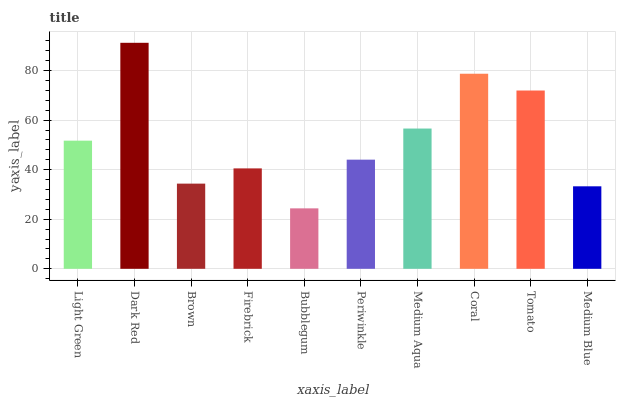Is Bubblegum the minimum?
Answer yes or no. Yes. Is Dark Red the maximum?
Answer yes or no. Yes. Is Brown the minimum?
Answer yes or no. No. Is Brown the maximum?
Answer yes or no. No. Is Dark Red greater than Brown?
Answer yes or no. Yes. Is Brown less than Dark Red?
Answer yes or no. Yes. Is Brown greater than Dark Red?
Answer yes or no. No. Is Dark Red less than Brown?
Answer yes or no. No. Is Light Green the high median?
Answer yes or no. Yes. Is Periwinkle the low median?
Answer yes or no. Yes. Is Periwinkle the high median?
Answer yes or no. No. Is Brown the low median?
Answer yes or no. No. 